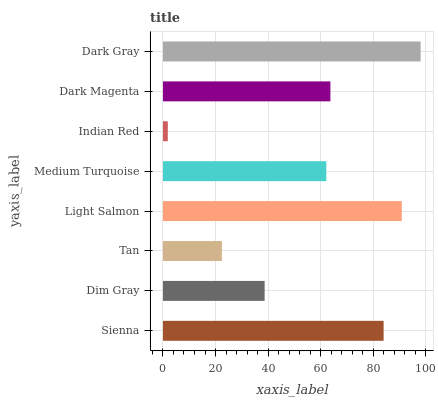Is Indian Red the minimum?
Answer yes or no. Yes. Is Dark Gray the maximum?
Answer yes or no. Yes. Is Dim Gray the minimum?
Answer yes or no. No. Is Dim Gray the maximum?
Answer yes or no. No. Is Sienna greater than Dim Gray?
Answer yes or no. Yes. Is Dim Gray less than Sienna?
Answer yes or no. Yes. Is Dim Gray greater than Sienna?
Answer yes or no. No. Is Sienna less than Dim Gray?
Answer yes or no. No. Is Dark Magenta the high median?
Answer yes or no. Yes. Is Medium Turquoise the low median?
Answer yes or no. Yes. Is Light Salmon the high median?
Answer yes or no. No. Is Dark Gray the low median?
Answer yes or no. No. 